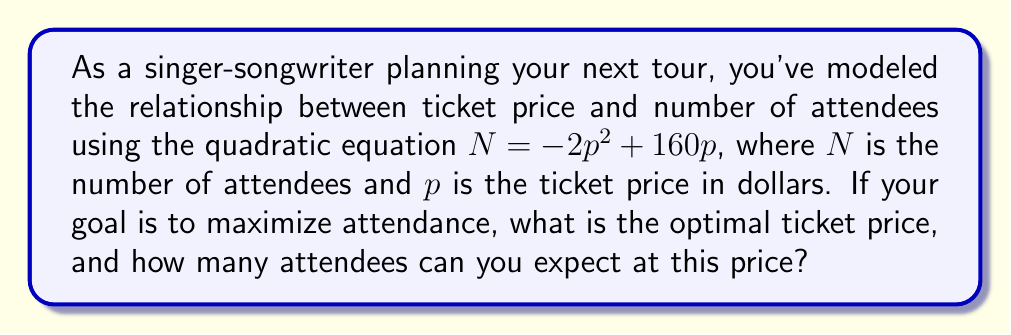Give your solution to this math problem. To find the optimal ticket price that maximizes attendance, we need to find the vertex of the parabola represented by the given quadratic equation.

1. The quadratic equation is in the form $N = -2p^2 + 160p$

2. For a quadratic equation in the form $f(x) = ax^2 + bx + c$, the x-coordinate of the vertex is given by $x = -\frac{b}{2a}$

3. In our case, $a = -2$ and $b = 160$

4. Substituting these values:
   $p = -\frac{160}{2(-2)} = -\frac{160}{-4} = 40$

5. The optimal ticket price is $40

6. To find the maximum number of attendees, substitute $p = 40$ into the original equation:
   $N = -2(40)^2 + 160(40)$
   $N = -2(1600) + 6400$
   $N = -3200 + 6400 = 3200$

Therefore, the optimal ticket price is $40, and the expected number of attendees at this price is 3200.
Answer: $40; 3200 